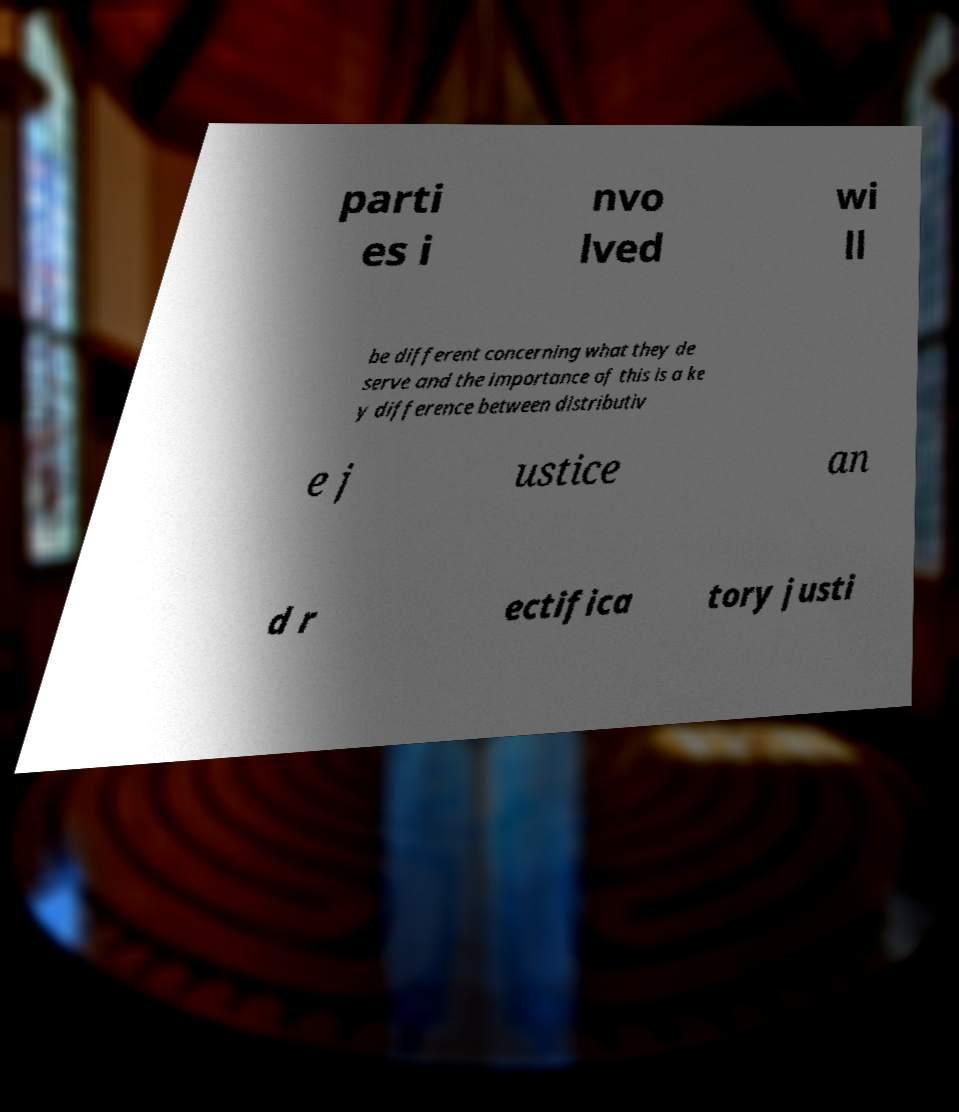There's text embedded in this image that I need extracted. Can you transcribe it verbatim? parti es i nvo lved wi ll be different concerning what they de serve and the importance of this is a ke y difference between distributiv e j ustice an d r ectifica tory justi 